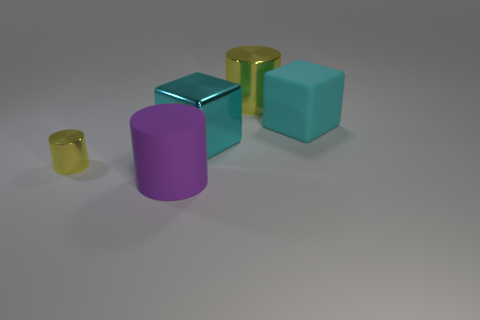There is a metallic cylinder that is the same size as the purple matte cylinder; what is its color?
Make the answer very short. Yellow. Do the big cyan cube left of the rubber block and the large cylinder that is behind the tiny metallic object have the same material?
Give a very brief answer. Yes. There is a shiny cylinder that is behind the metal object that is to the left of the purple cylinder; how big is it?
Your answer should be compact. Large. There is a yellow cylinder to the right of the purple matte cylinder; what is its material?
Provide a succinct answer. Metal. What number of objects are either yellow objects that are to the right of the large rubber cylinder or large yellow things on the right side of the large purple thing?
Keep it short and to the point. 1. There is another object that is the same shape as the cyan matte object; what is its material?
Give a very brief answer. Metal. There is a big cylinder behind the cyan metallic thing; does it have the same color as the big rubber object left of the large metallic cube?
Ensure brevity in your answer.  No. Is there another thing of the same size as the purple rubber object?
Provide a short and direct response. Yes. What is the material of the thing that is right of the large metallic cube and to the left of the cyan matte thing?
Your response must be concise. Metal. What number of rubber things are either big purple objects or brown cubes?
Offer a very short reply. 1. 